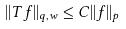Convert formula to latex. <formula><loc_0><loc_0><loc_500><loc_500>| | T f | | _ { q , w } \leq C | | f | | _ { p }</formula> 